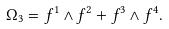<formula> <loc_0><loc_0><loc_500><loc_500>\Omega _ { 3 } = f ^ { 1 } \wedge f ^ { 2 } + f ^ { 3 } \wedge f ^ { 4 } .</formula> 